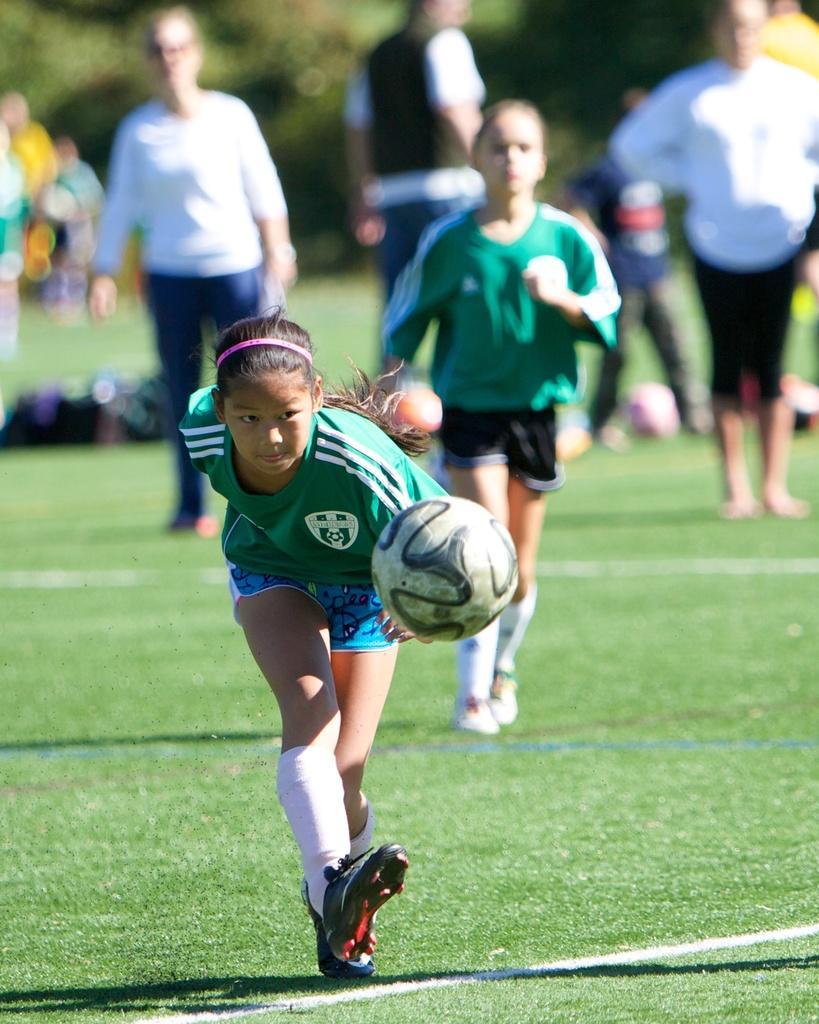Please provide a concise description of this image. In this image we can see two girls who are playing a football. In the background we can see a few persons who are standing. 